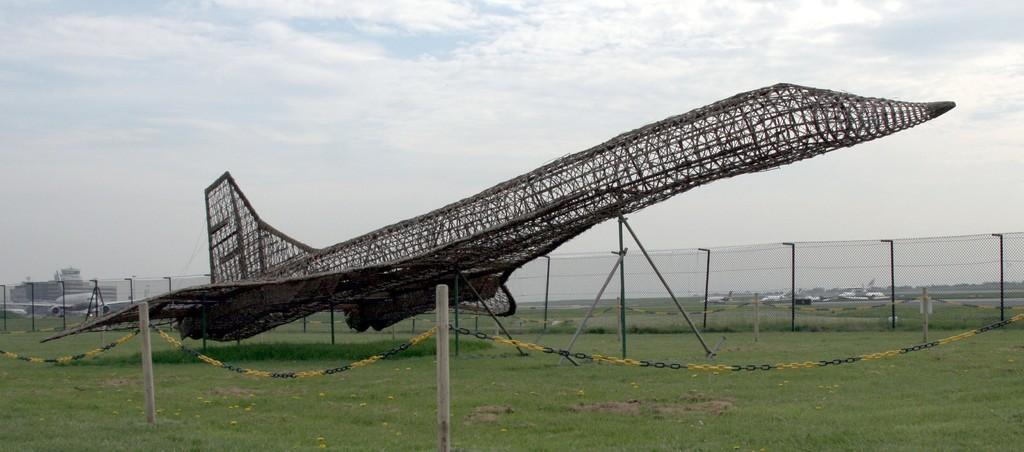Describe this image in one or two sentences. In the middle of the picture, we see an object which is made up of rods. This object looks like an airplane. At the bottom, we see the grass and the barrier poles. We see the chain in yellow and black color. Behind that, we see the poles and the fence. On the left side, we see an airplane. Behind that, we see a building in white color. There are airplanes and trees in the background. At the top, we see the sky and the clouds. 